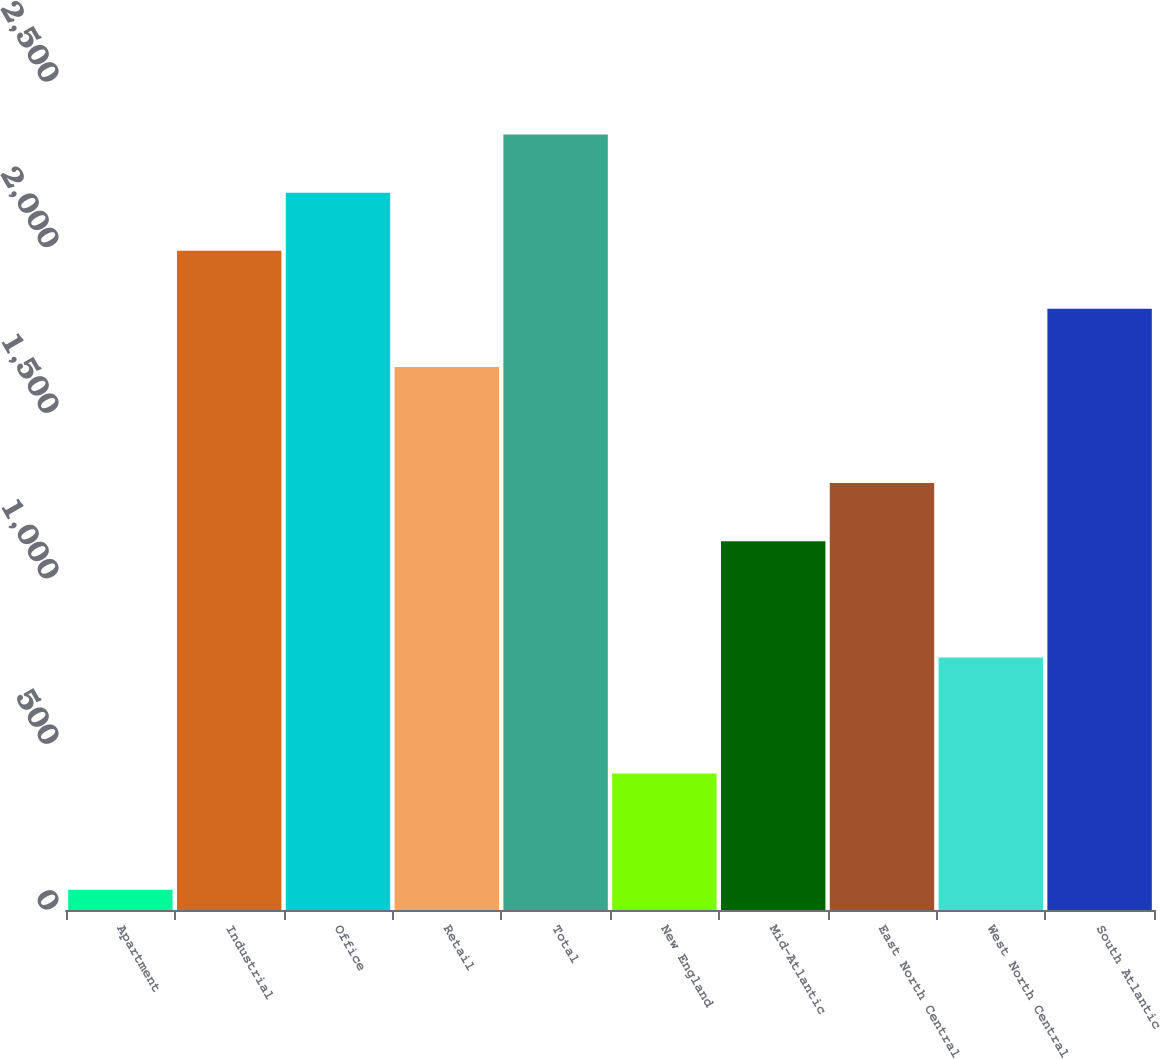Convert chart. <chart><loc_0><loc_0><loc_500><loc_500><bar_chart><fcel>Apartment<fcel>Industrial<fcel>Office<fcel>Retail<fcel>Total<fcel>New England<fcel>Mid-Atlantic<fcel>East North Central<fcel>West North Central<fcel>South Atlantic<nl><fcel>61.1<fcel>1990.5<fcel>2165.9<fcel>1639.7<fcel>2341.3<fcel>411.9<fcel>1113.5<fcel>1288.9<fcel>762.7<fcel>1815.1<nl></chart> 